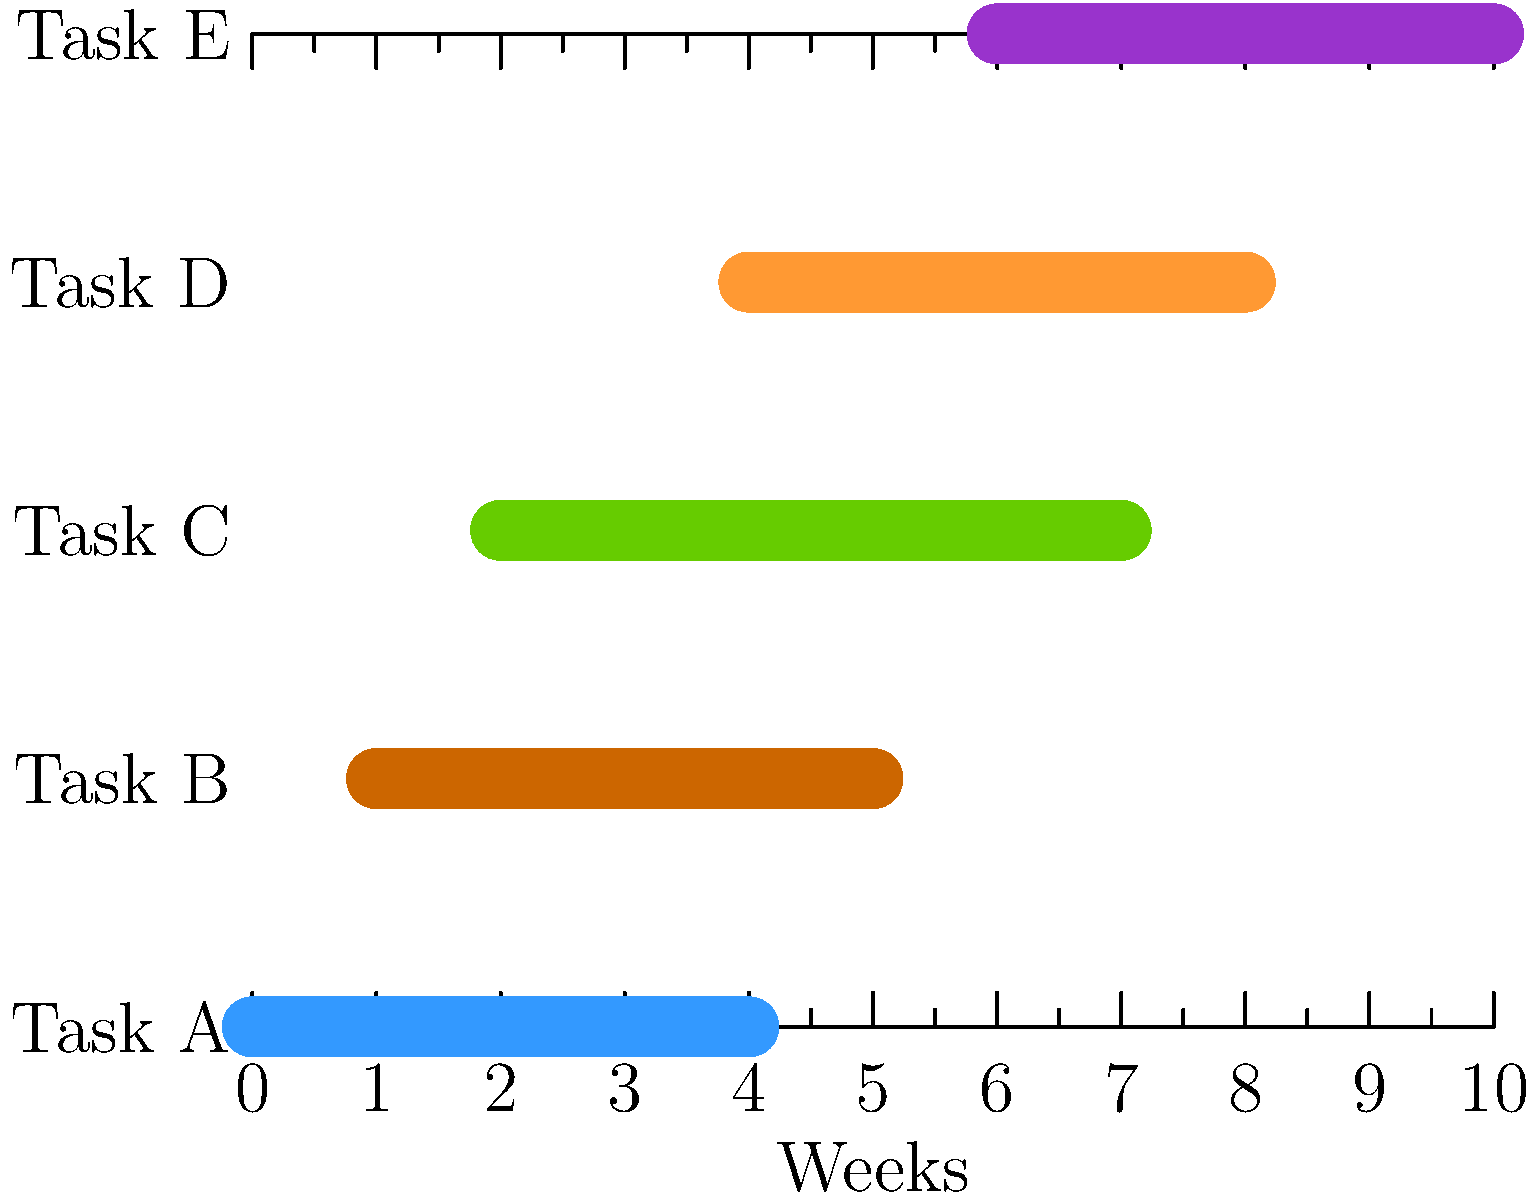As a developer concerned about financial burdens, you're reviewing a project Gantt chart. The chart shows 5 tasks (A to E) over a 10-week period. If each task requires one full-time developer and the company charges $2000 per developer-week, what's the minimum budget needed to complete the project, assuming perfect resource allocation and no idle time? To solve this problem, we need to follow these steps:

1. Determine the duration of each task:
   Task A: 4 weeks
   Task B: 4 weeks
   Task C: 5 weeks
   Task D: 4 weeks
   Task E: 4 weeks

2. Calculate the total number of developer-weeks:
   $4 + 4 + 5 + 4 + 4 = 21$ developer-weeks

3. Identify potential overlaps to minimize idle time:
   - Tasks A and B can be done simultaneously for 3 weeks
   - Tasks C and D can be done simultaneously for 3 weeks
   - Task E can start immediately after D

4. Calculate the minimum project duration with perfect resource allocation:
   $4 + 2 + 4 = 10$ weeks (as shown in the Gantt chart)

5. Calculate the minimum number of developer-weeks needed:
   $10$ weeks * $1$ developer = $10$ developer-weeks

6. Calculate the minimum budget:
   $10$ developer-weeks * $\$2000$ per developer-week = $\$20,000$

This approach ensures no idle time and minimizes the project cost, addressing the financial concerns of the developer persona.
Answer: $20,000 